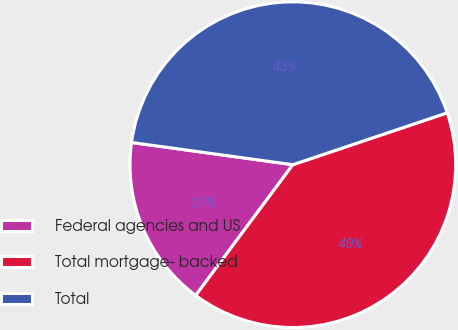Convert chart. <chart><loc_0><loc_0><loc_500><loc_500><pie_chart><fcel>Federal agencies and US<fcel>Total mortgage- backed<fcel>Total<nl><fcel>17.01%<fcel>40.33%<fcel>42.66%<nl></chart> 